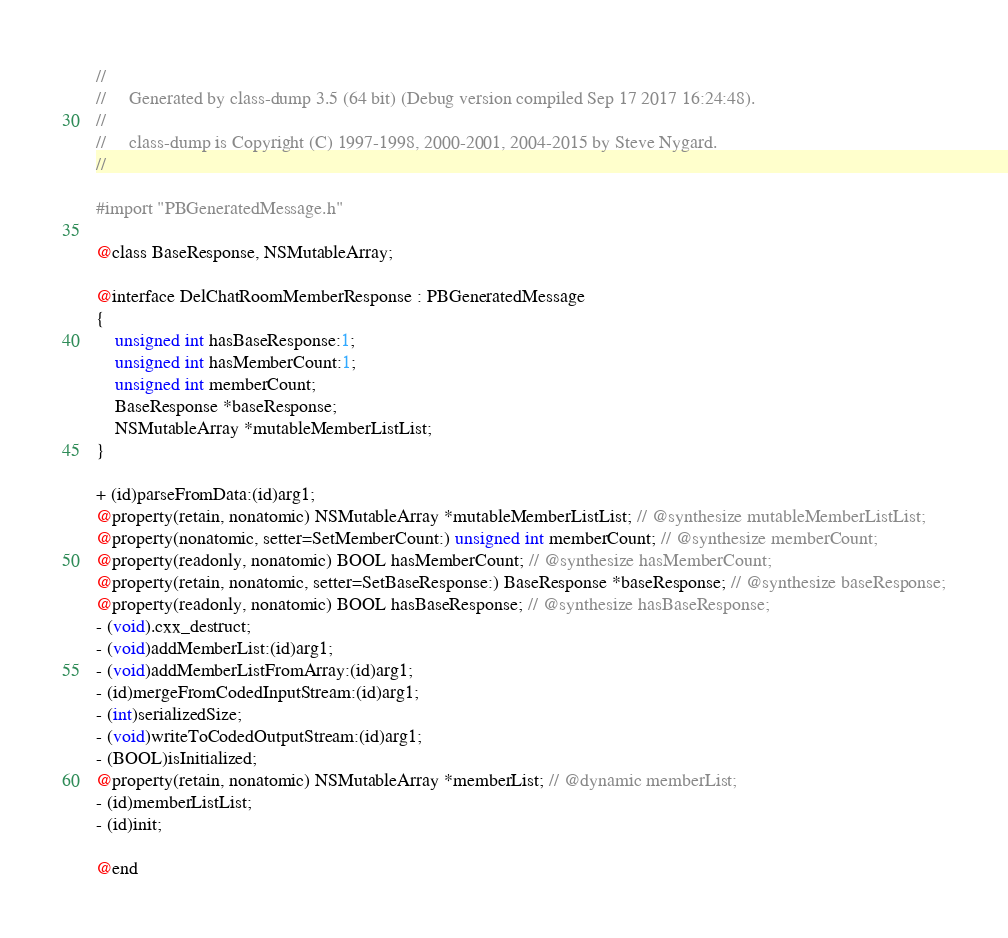<code> <loc_0><loc_0><loc_500><loc_500><_C_>//
//     Generated by class-dump 3.5 (64 bit) (Debug version compiled Sep 17 2017 16:24:48).
//
//     class-dump is Copyright (C) 1997-1998, 2000-2001, 2004-2015 by Steve Nygard.
//

#import "PBGeneratedMessage.h"

@class BaseResponse, NSMutableArray;

@interface DelChatRoomMemberResponse : PBGeneratedMessage
{
    unsigned int hasBaseResponse:1;
    unsigned int hasMemberCount:1;
    unsigned int memberCount;
    BaseResponse *baseResponse;
    NSMutableArray *mutableMemberListList;
}

+ (id)parseFromData:(id)arg1;
@property(retain, nonatomic) NSMutableArray *mutableMemberListList; // @synthesize mutableMemberListList;
@property(nonatomic, setter=SetMemberCount:) unsigned int memberCount; // @synthesize memberCount;
@property(readonly, nonatomic) BOOL hasMemberCount; // @synthesize hasMemberCount;
@property(retain, nonatomic, setter=SetBaseResponse:) BaseResponse *baseResponse; // @synthesize baseResponse;
@property(readonly, nonatomic) BOOL hasBaseResponse; // @synthesize hasBaseResponse;
- (void).cxx_destruct;
- (void)addMemberList:(id)arg1;
- (void)addMemberListFromArray:(id)arg1;
- (id)mergeFromCodedInputStream:(id)arg1;
- (int)serializedSize;
- (void)writeToCodedOutputStream:(id)arg1;
- (BOOL)isInitialized;
@property(retain, nonatomic) NSMutableArray *memberList; // @dynamic memberList;
- (id)memberListList;
- (id)init;

@end

</code> 